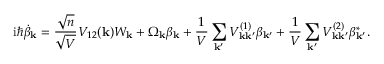<formula> <loc_0><loc_0><loc_500><loc_500>i \hbar { \dot } { \beta } _ { k } = \frac { \sqrt { n } } { \sqrt { V } } V _ { 1 2 } ( k ) W _ { k } + \Omega _ { k } \beta _ { k } + \frac { 1 } { V } \sum _ { k ^ { \prime } } V _ { k k ^ { \prime } } ^ { ( 1 ) } \beta _ { k ^ { \prime } } + \frac { 1 } { V } \sum _ { k ^ { \prime } } V _ { k k ^ { \prime } } ^ { ( 2 ) } \beta _ { k ^ { \prime } } ^ { * } .</formula> 